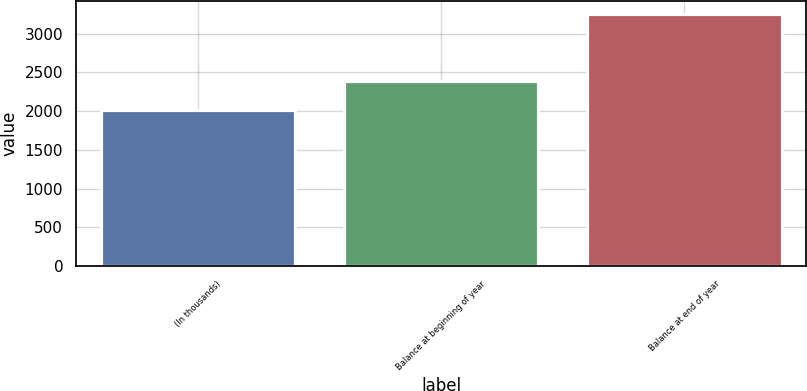<chart> <loc_0><loc_0><loc_500><loc_500><bar_chart><fcel>(In thousands)<fcel>Balance at beginning of year<fcel>Balance at end of year<nl><fcel>2014<fcel>2385<fcel>3255<nl></chart> 